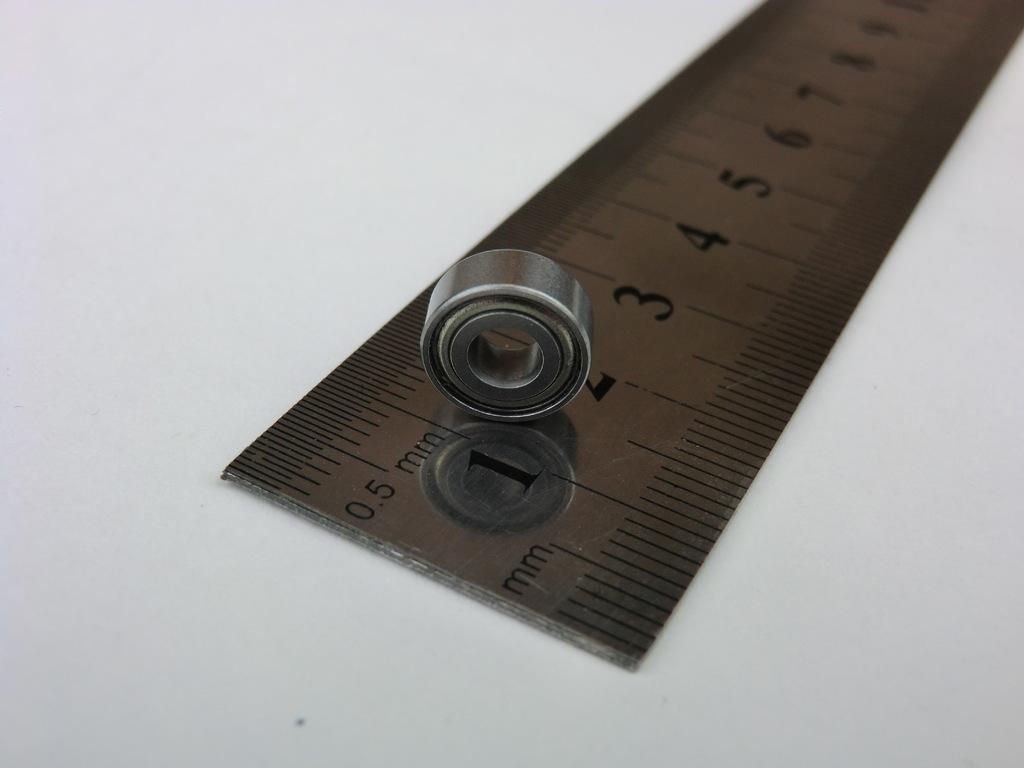<image>
Give a short and clear explanation of the subsequent image. A silver ruler that measure in mm with a nut on it. 